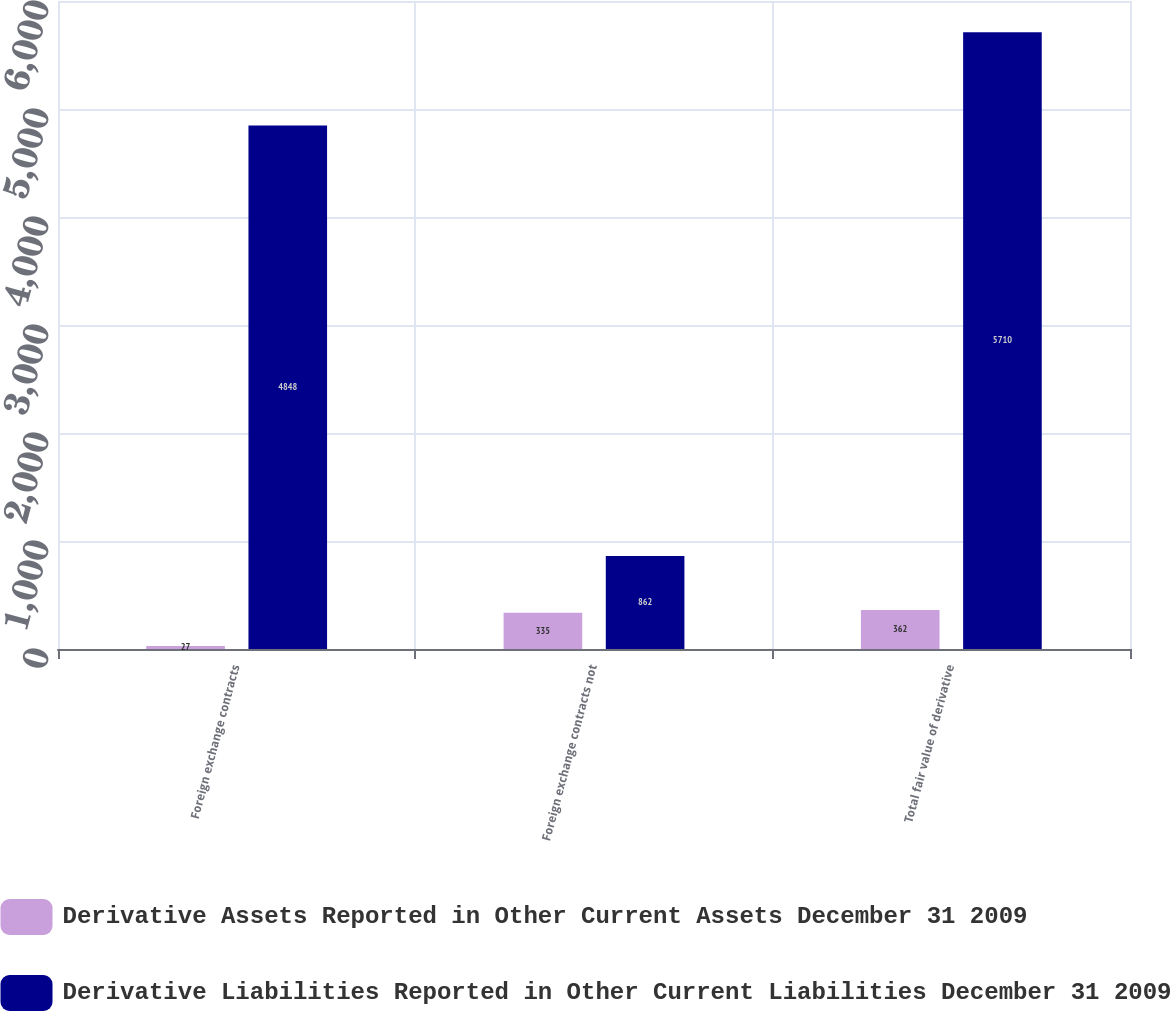<chart> <loc_0><loc_0><loc_500><loc_500><stacked_bar_chart><ecel><fcel>Foreign exchange contracts<fcel>Foreign exchange contracts not<fcel>Total fair value of derivative<nl><fcel>Derivative Assets Reported in Other Current Assets December 31 2009<fcel>27<fcel>335<fcel>362<nl><fcel>Derivative Liabilities Reported in Other Current Liabilities December 31 2009<fcel>4848<fcel>862<fcel>5710<nl></chart> 